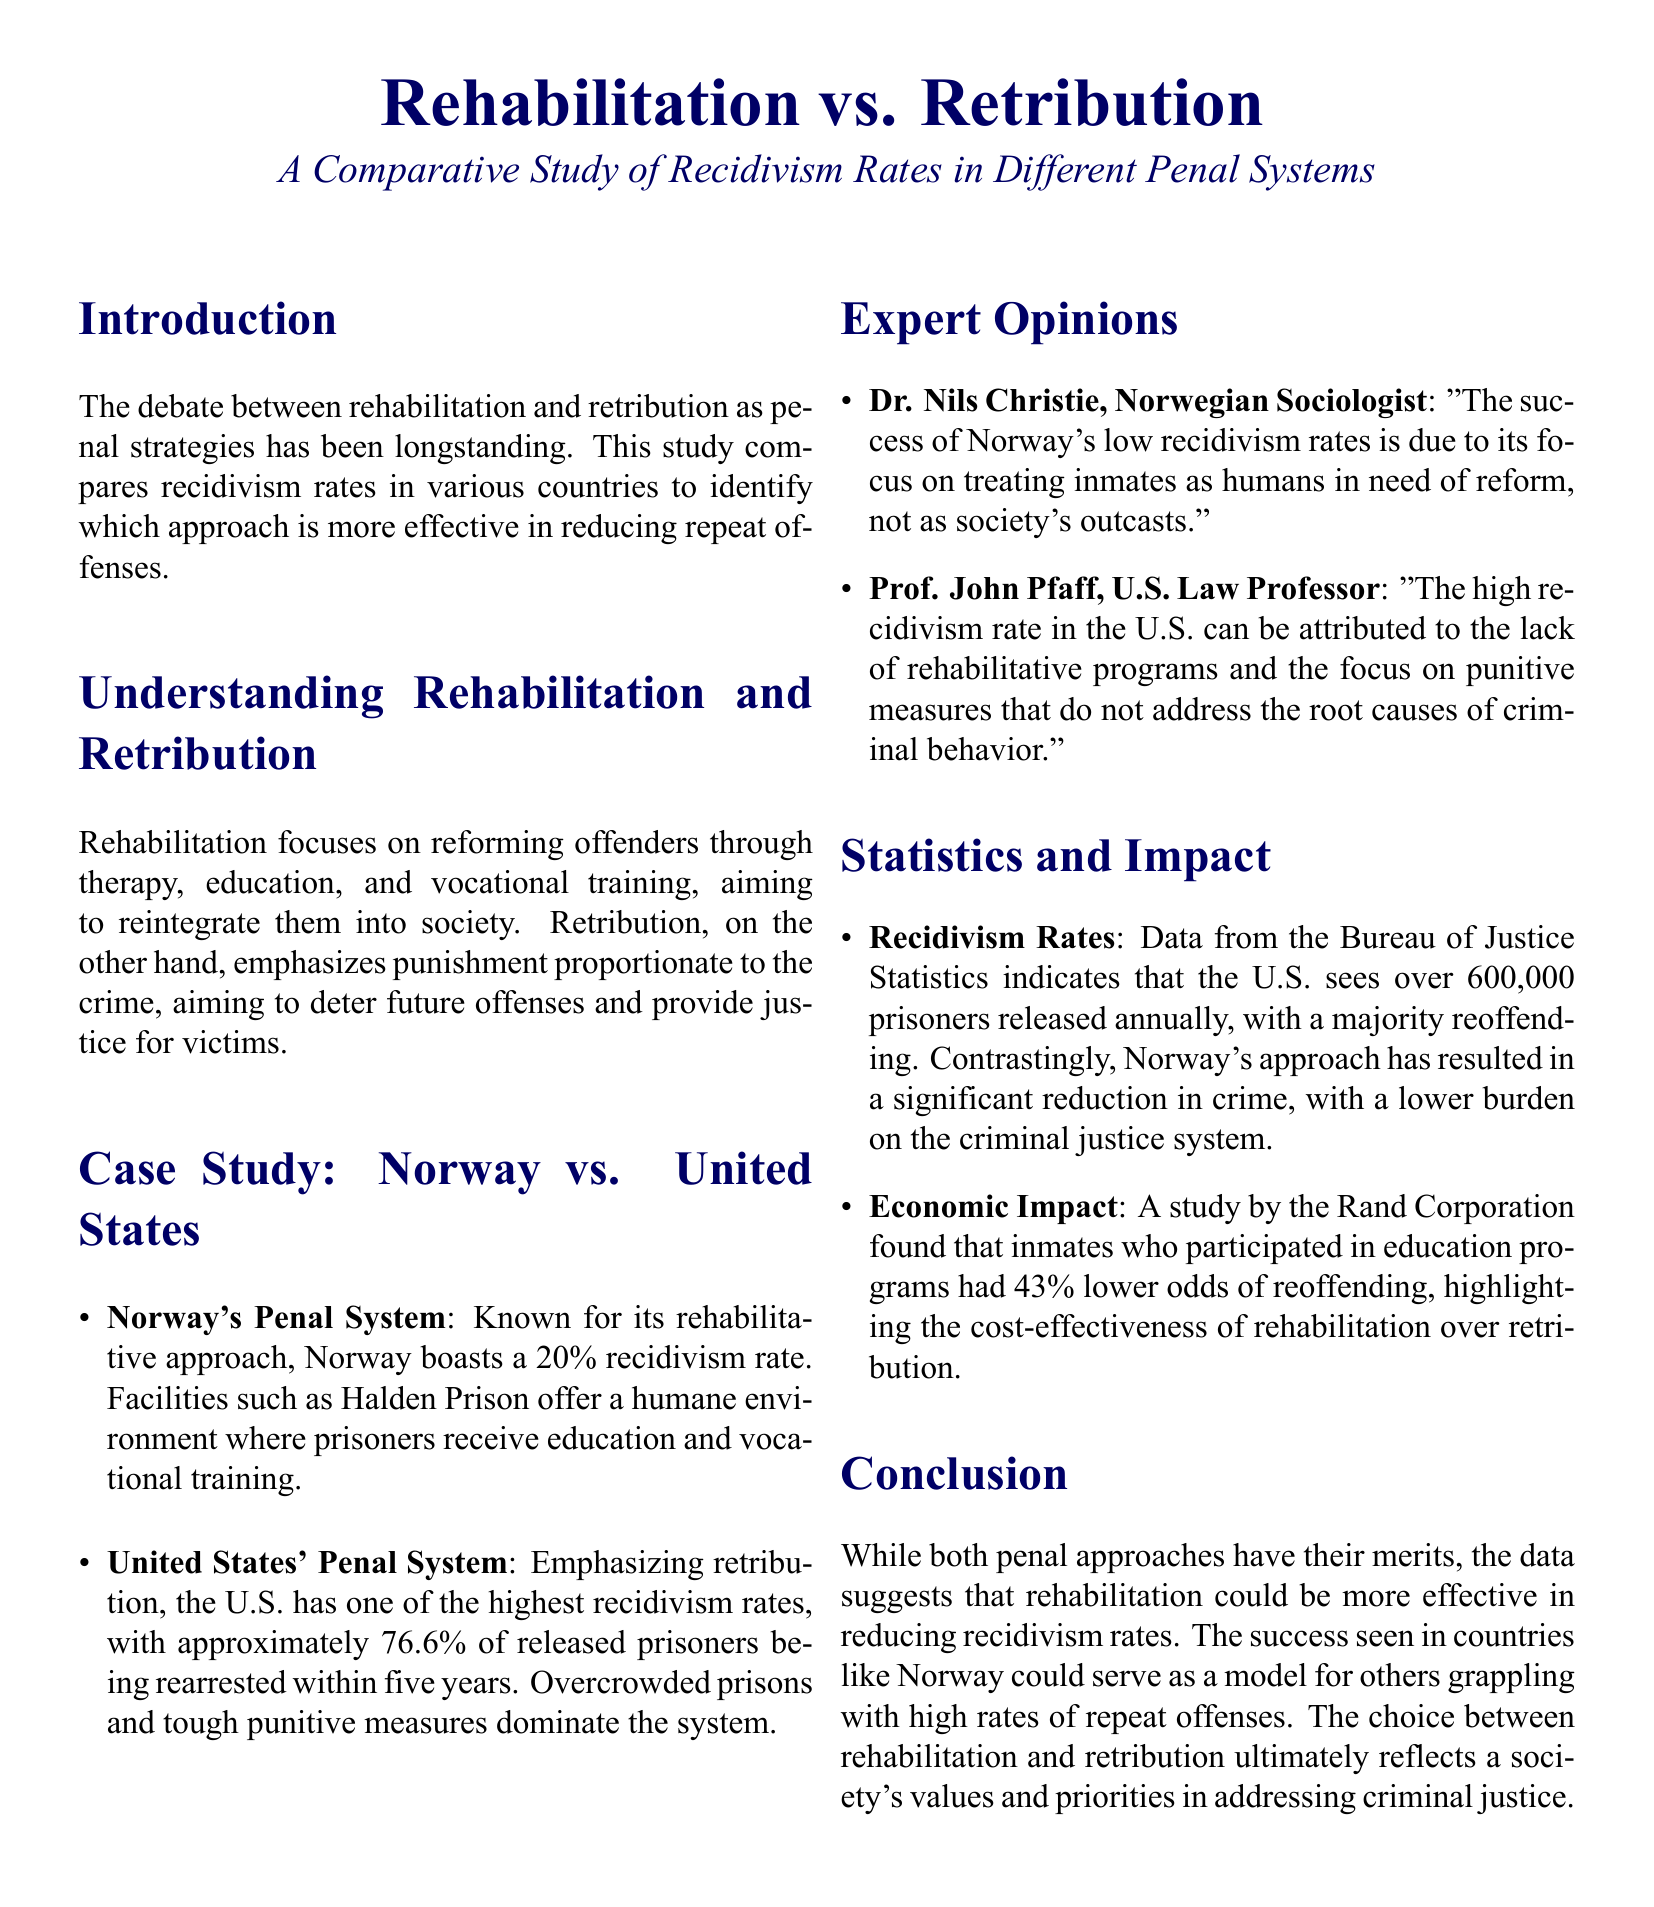What is the recidivism rate in Norway? The document states that Norway boasts a 20% recidivism rate.
Answer: 20% What is the recidivism rate in the United States? According to the document, the U.S. has approximately 76.6% of released prisoners being rearrested within five years.
Answer: 76.6% Which country is highlighted as having a rehabilitative approach? The document identifies Norway's penal system as known for its rehabilitative approach.
Answer: Norway What is one reason cited for the high recidivism rate in the U.S.? The document mentions the lack of rehabilitative programs and the focus on punitive measures as reasons for the high recidivism rate.
Answer: Lack of rehabilitative programs Who is Dr. Nils Christie? The document describes Dr. Nils Christie as a Norwegian Sociologist who commented on Norway's low recidivism rates.
Answer: Norwegian Sociologist What organization conducted a study on the cost-effectiveness of rehabilitation? The document refers to a study by the Rand Corporation related to education programs and their impact on recidivism.
Answer: Rand Corporation What type of penal strategy emphasizes punishment proportionate to the crime? The document states that retribution is the penal strategy that emphasizes punishment proportionate to the crime.
Answer: Retribution What is the main aim of rehabilitation according to the document? The document explains that rehabilitation aims to reform offenders through therapy, education, and vocational training.
Answer: Reforming offenders What type of penal system does the United States emphasize? The document states that the U.S. emphasizes retribution in its penal system.
Answer: Retribution 